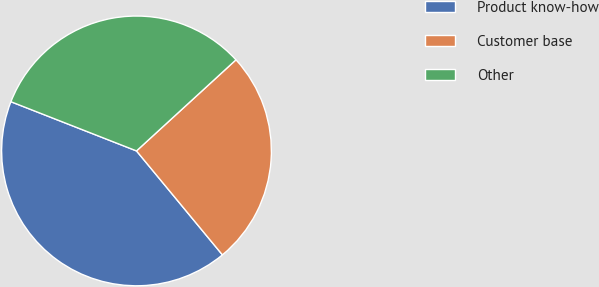Convert chart. <chart><loc_0><loc_0><loc_500><loc_500><pie_chart><fcel>Product know-how<fcel>Customer base<fcel>Other<nl><fcel>41.94%<fcel>25.81%<fcel>32.26%<nl></chart> 